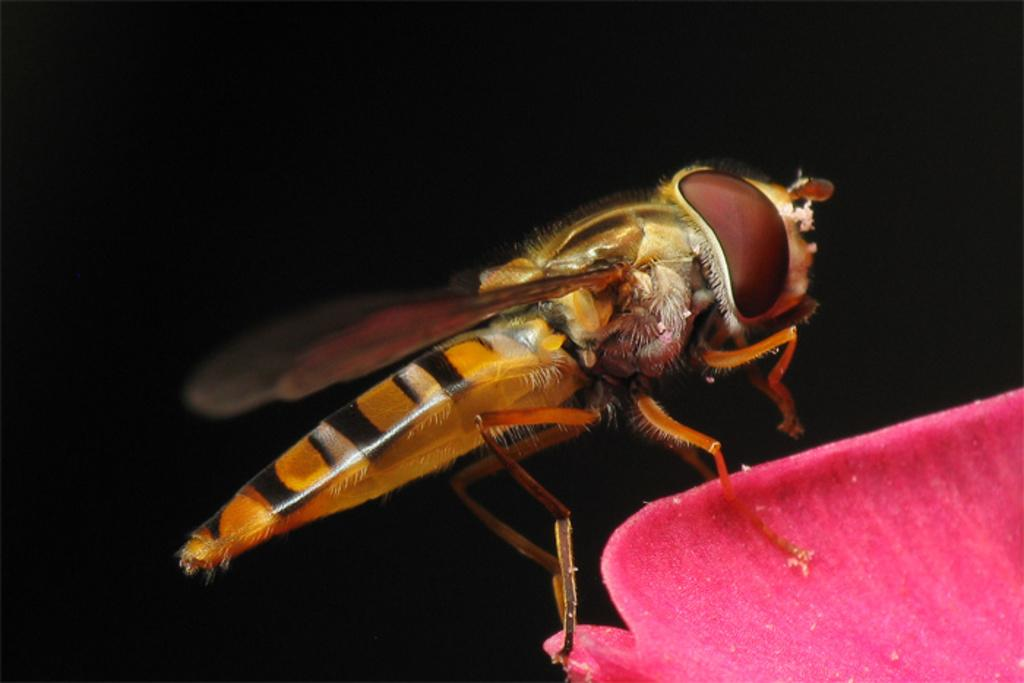What type of creature can be seen in the image? There is an insect in the image. What color is the insect? The insect is brown in color. What type of lumber is being used to build the boat in the image? There is no boat or lumber present in the image; it only features an insect. 